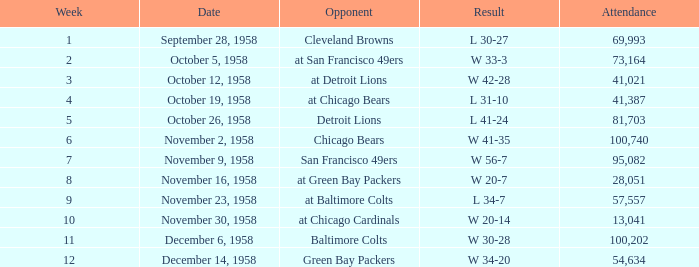Give me the full table as a dictionary. {'header': ['Week', 'Date', 'Opponent', 'Result', 'Attendance'], 'rows': [['1', 'September 28, 1958', 'Cleveland Browns', 'L 30-27', '69,993'], ['2', 'October 5, 1958', 'at San Francisco 49ers', 'W 33-3', '73,164'], ['3', 'October 12, 1958', 'at Detroit Lions', 'W 42-28', '41,021'], ['4', 'October 19, 1958', 'at Chicago Bears', 'L 31-10', '41,387'], ['5', 'October 26, 1958', 'Detroit Lions', 'L 41-24', '81,703'], ['6', 'November 2, 1958', 'Chicago Bears', 'W 41-35', '100,740'], ['7', 'November 9, 1958', 'San Francisco 49ers', 'W 56-7', '95,082'], ['8', 'November 16, 1958', 'at Green Bay Packers', 'W 20-7', '28,051'], ['9', 'November 23, 1958', 'at Baltimore Colts', 'L 34-7', '57,557'], ['10', 'November 30, 1958', 'at Chicago Cardinals', 'W 20-14', '13,041'], ['11', 'December 6, 1958', 'Baltimore Colts', 'W 30-28', '100,202'], ['12', 'December 14, 1958', 'Green Bay Packers', 'W 34-20', '54,634']]} What was the maximum attendance on november 9, 1958? 95082.0. 